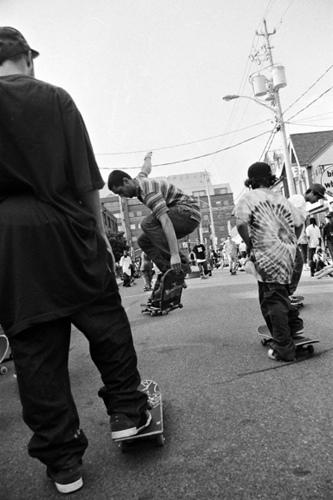Are there electrical transformers visible?
Answer briefly. Yes. How many people are shown?
Answer briefly. 3. How many of them are wearing baseball caps?
Be succinct. 2. Is that kid on the right wearing a tie-dye shirt?
Concise answer only. Yes. What are they doing?
Give a very brief answer. Skateboarding. 